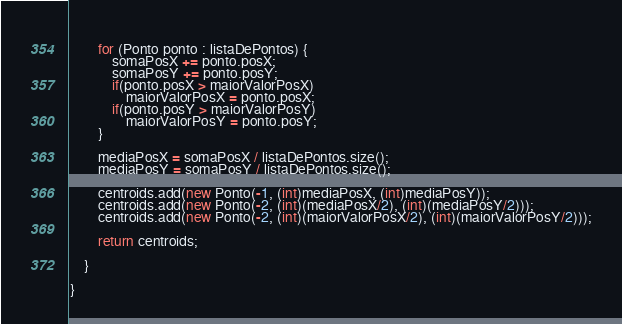<code> <loc_0><loc_0><loc_500><loc_500><_Java_>		
		for (Ponto ponto : listaDePontos) {
			somaPosX += ponto.posX;
			somaPosY += ponto.posY;
			if(ponto.posX > maiorValorPosX) 
				maiorValorPosX = ponto.posX;
			if(ponto.posY > maiorValorPosY)
				maiorValorPosY = ponto.posY;
		}
		
		mediaPosX = somaPosX / listaDePontos.size();
		mediaPosY = somaPosY / listaDePontos.size();
		
		centroids.add(new Ponto(-1, (int)mediaPosX, (int)mediaPosY));
		centroids.add(new Ponto(-2, (int)(mediaPosX/2), (int)(mediaPosY/2)));
		centroids.add(new Ponto(-2, (int)(maiorValorPosX/2), (int)(maiorValorPosY/2)));
		
		return centroids;
		
	}
	
}
</code> 